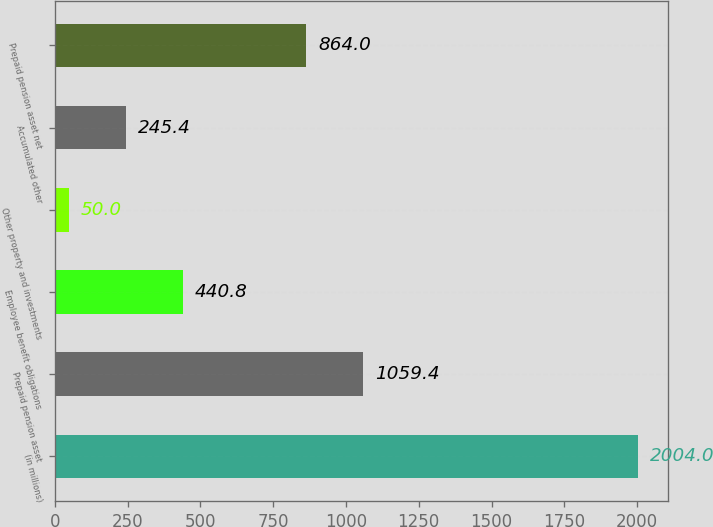Convert chart. <chart><loc_0><loc_0><loc_500><loc_500><bar_chart><fcel>(in millions)<fcel>Prepaid pension asset<fcel>Employee benefit obligations<fcel>Other property and investments<fcel>Accumulated other<fcel>Prepaid pension asset net<nl><fcel>2004<fcel>1059.4<fcel>440.8<fcel>50<fcel>245.4<fcel>864<nl></chart> 